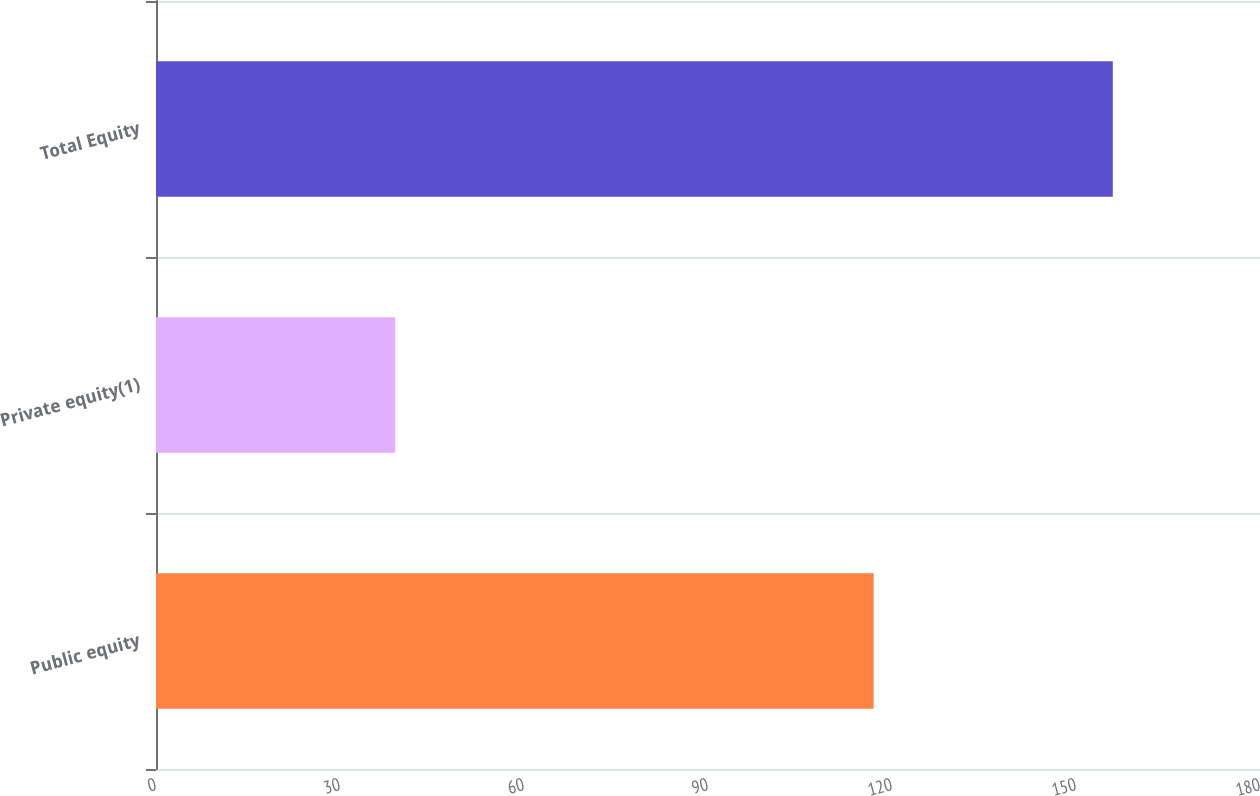<chart> <loc_0><loc_0><loc_500><loc_500><bar_chart><fcel>Public equity<fcel>Private equity(1)<fcel>Total Equity<nl><fcel>117<fcel>39<fcel>156<nl></chart> 